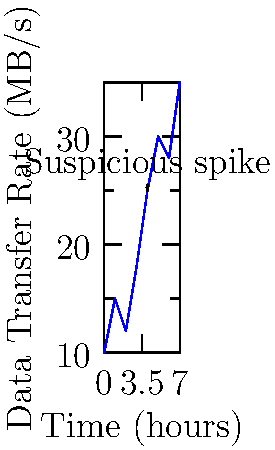Based on the network traffic pattern shown in the graph, which time period would you recommend focusing the investigation on for potential data leaks or security breaches? To identify potential security breaches or data leaks, we need to analyze the network traffic pattern for any anomalies or unexpected spikes. Let's examine the graph step-by-step:

1. The x-axis represents time in hours, while the y-axis shows the data transfer rate in MB/s.
2. The graph shows a general upward trend in data transfer rate over time.
3. Most of the increases in data transfer rate appear gradual and consistent with normal network usage.
4. However, there is a significant spike in data transfer rate at the 4-hour mark.
5. This sudden increase from approximately 18 MB/s to 25 MB/s is much steeper than the other changes in the graph.
6. Such an abrupt and substantial increase in data transfer rate could indicate:
   a) A large-scale data transfer that might be unauthorized
   b) A potential security breach where an attacker is exfiltrating data
   c) A malware infection that is causing abnormal network activity
7. The period immediately following this spike (hours 4-5) also shows a continued high level of data transfer, which could be part of the same event.

Given this analysis, the most suspicious period for potential data leaks or security breaches is the time around the 4-hour mark, where the sudden spike in data transfer rate occurs.
Answer: 4-hour mark 